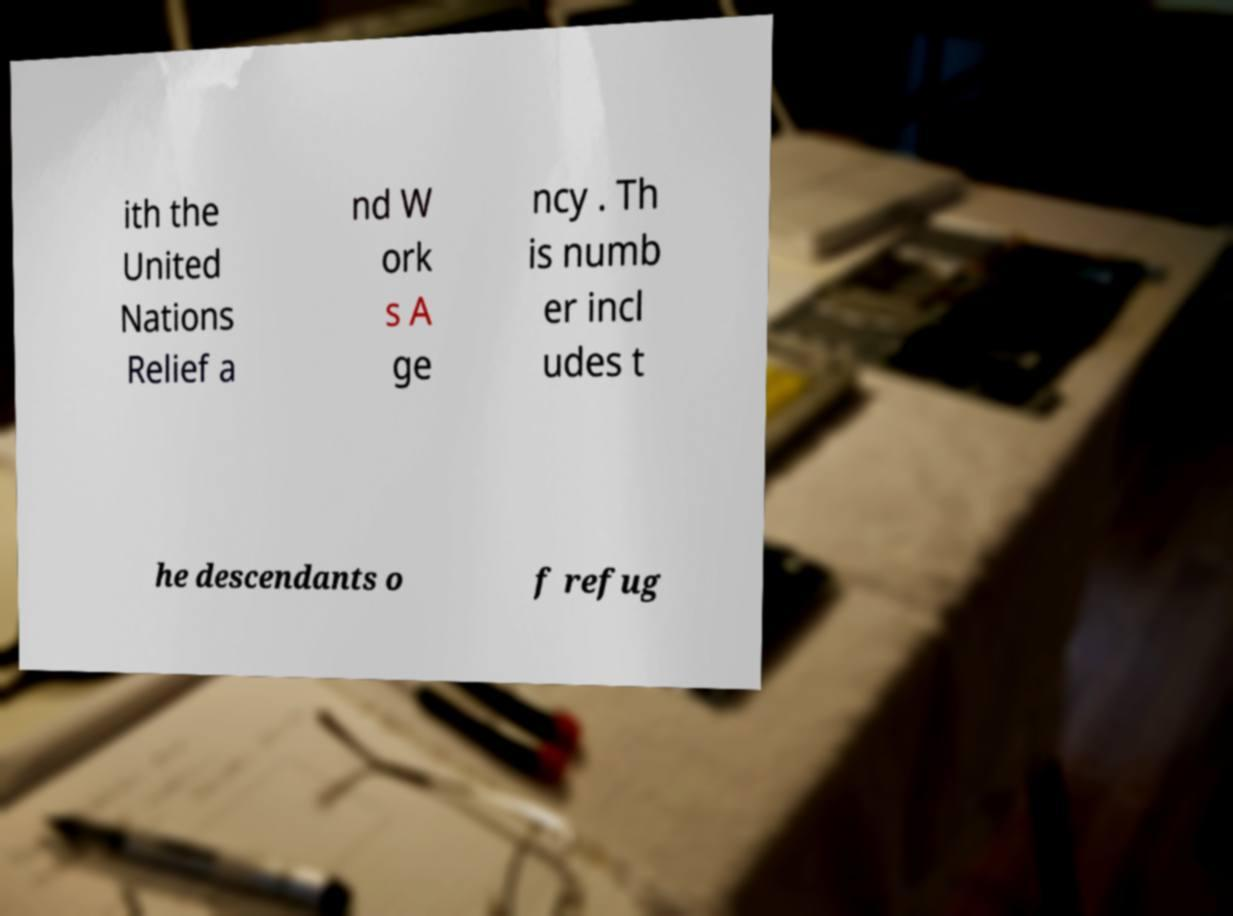Could you extract and type out the text from this image? ith the United Nations Relief a nd W ork s A ge ncy . Th is numb er incl udes t he descendants o f refug 